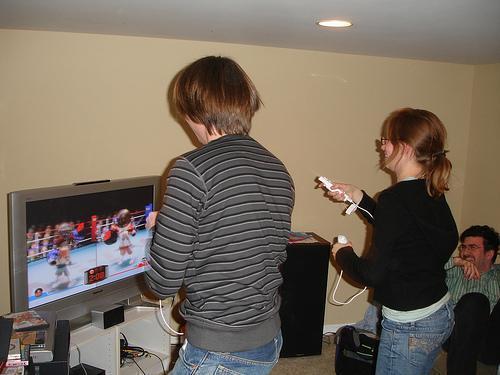How many people are pictured?
Give a very brief answer. 3. How many people are standing?
Give a very brief answer. 2. How many people are female?
Give a very brief answer. 1. How many people are wearing glasses?
Give a very brief answer. 2. 